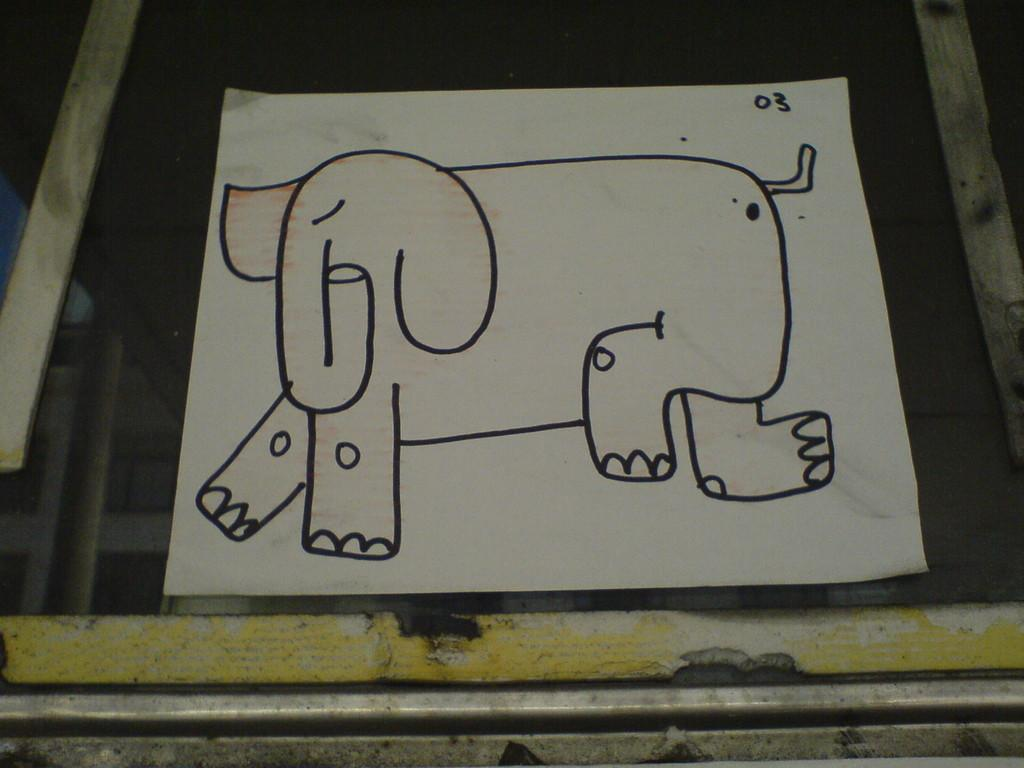What is depicted on the paper in the image? There is an elephant image drawn on a paper. Where is the paper located in the image? The paper is kept on a table. What type of thrill can be experienced by the elephant in the image? There is no indication of any thrill or emotion in the image, as it is a static drawing of an elephant on a paper. 